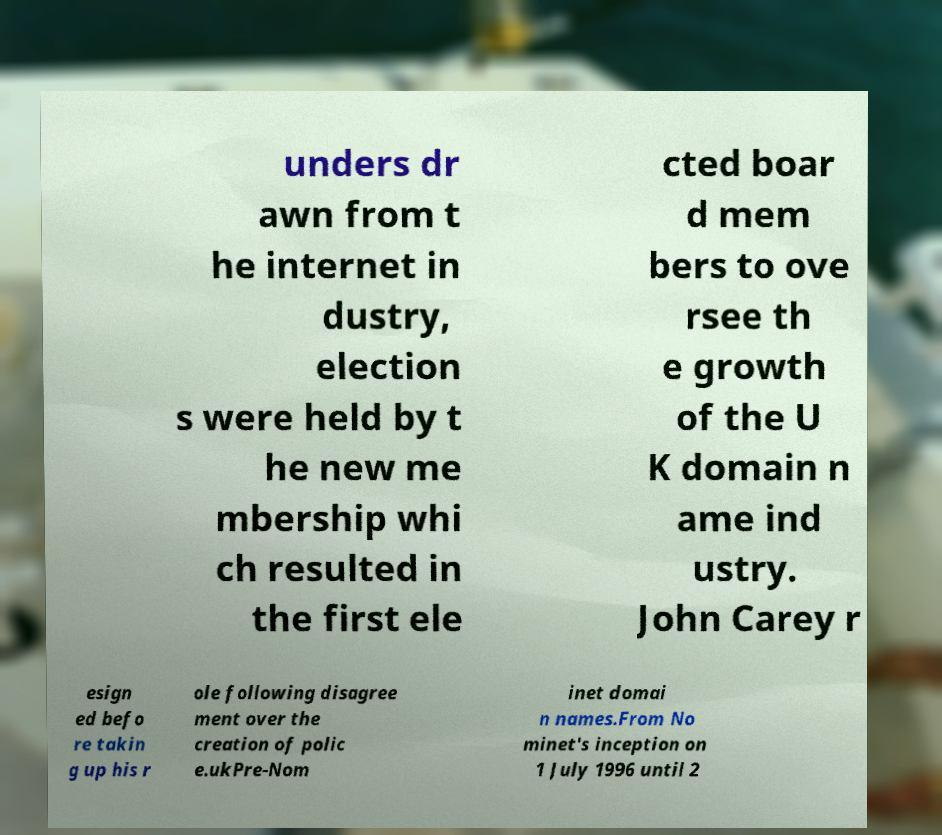I need the written content from this picture converted into text. Can you do that? unders dr awn from t he internet in dustry, election s were held by t he new me mbership whi ch resulted in the first ele cted boar d mem bers to ove rsee th e growth of the U K domain n ame ind ustry. John Carey r esign ed befo re takin g up his r ole following disagree ment over the creation of polic e.ukPre-Nom inet domai n names.From No minet's inception on 1 July 1996 until 2 